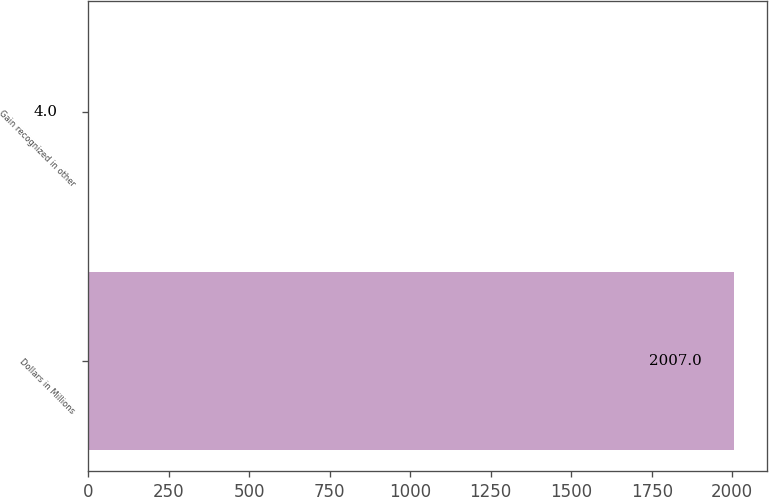Convert chart. <chart><loc_0><loc_0><loc_500><loc_500><bar_chart><fcel>Dollars in Millions<fcel>Gain recognized in other<nl><fcel>2007<fcel>4<nl></chart> 